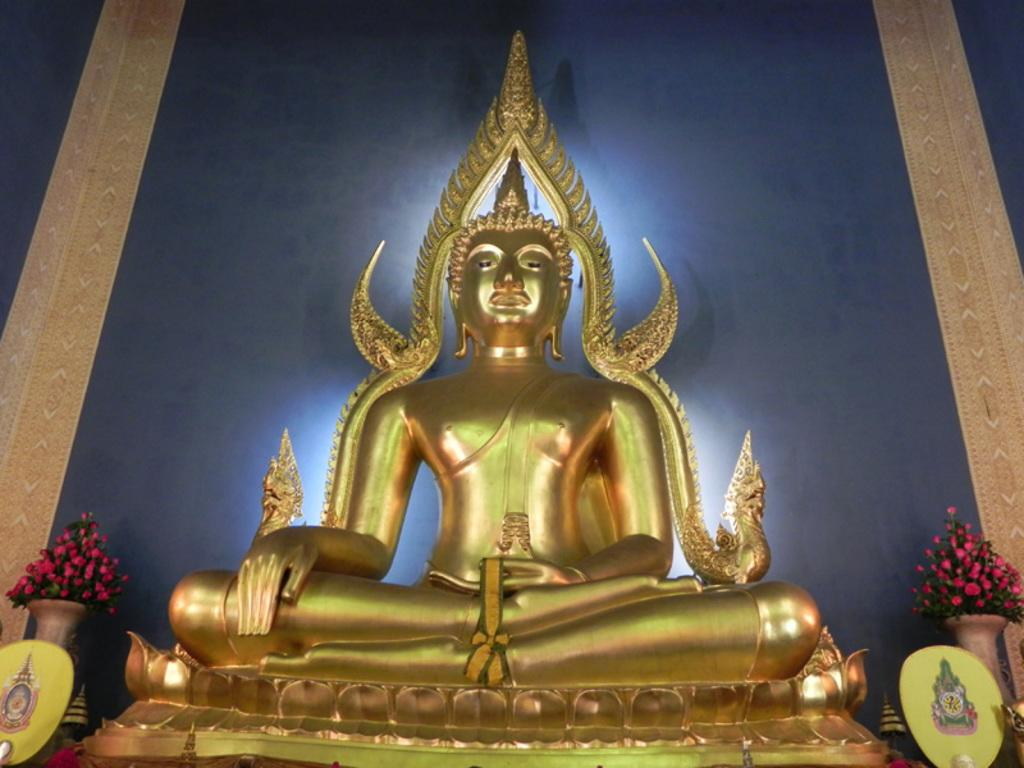What is the main subject in the image? There is a statue in the image. What is located in the foreground of the image? There is a ribbon in the foreground of the image. What can be seen in the background of the image? There are boards with pictures and flowers in vases in the background of the image. What type of structure is visible in the background of the image? There is a wall visible in the background of the image. What color is the sock on the statue's foot in the image? There is no sock present on the statue's foot in the image. How many hydrants are visible in the image? There are no hydrants present in the image. 